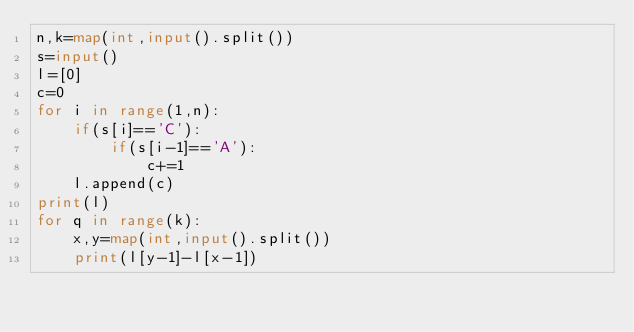<code> <loc_0><loc_0><loc_500><loc_500><_Python_>n,k=map(int,input().split())
s=input()
l=[0]
c=0
for i in range(1,n):
    if(s[i]=='C'):
        if(s[i-1]=='A'):
            c+=1
    l.append(c)
print(l)
for q in range(k):
    x,y=map(int,input().split())
    print(l[y-1]-l[x-1])

</code> 